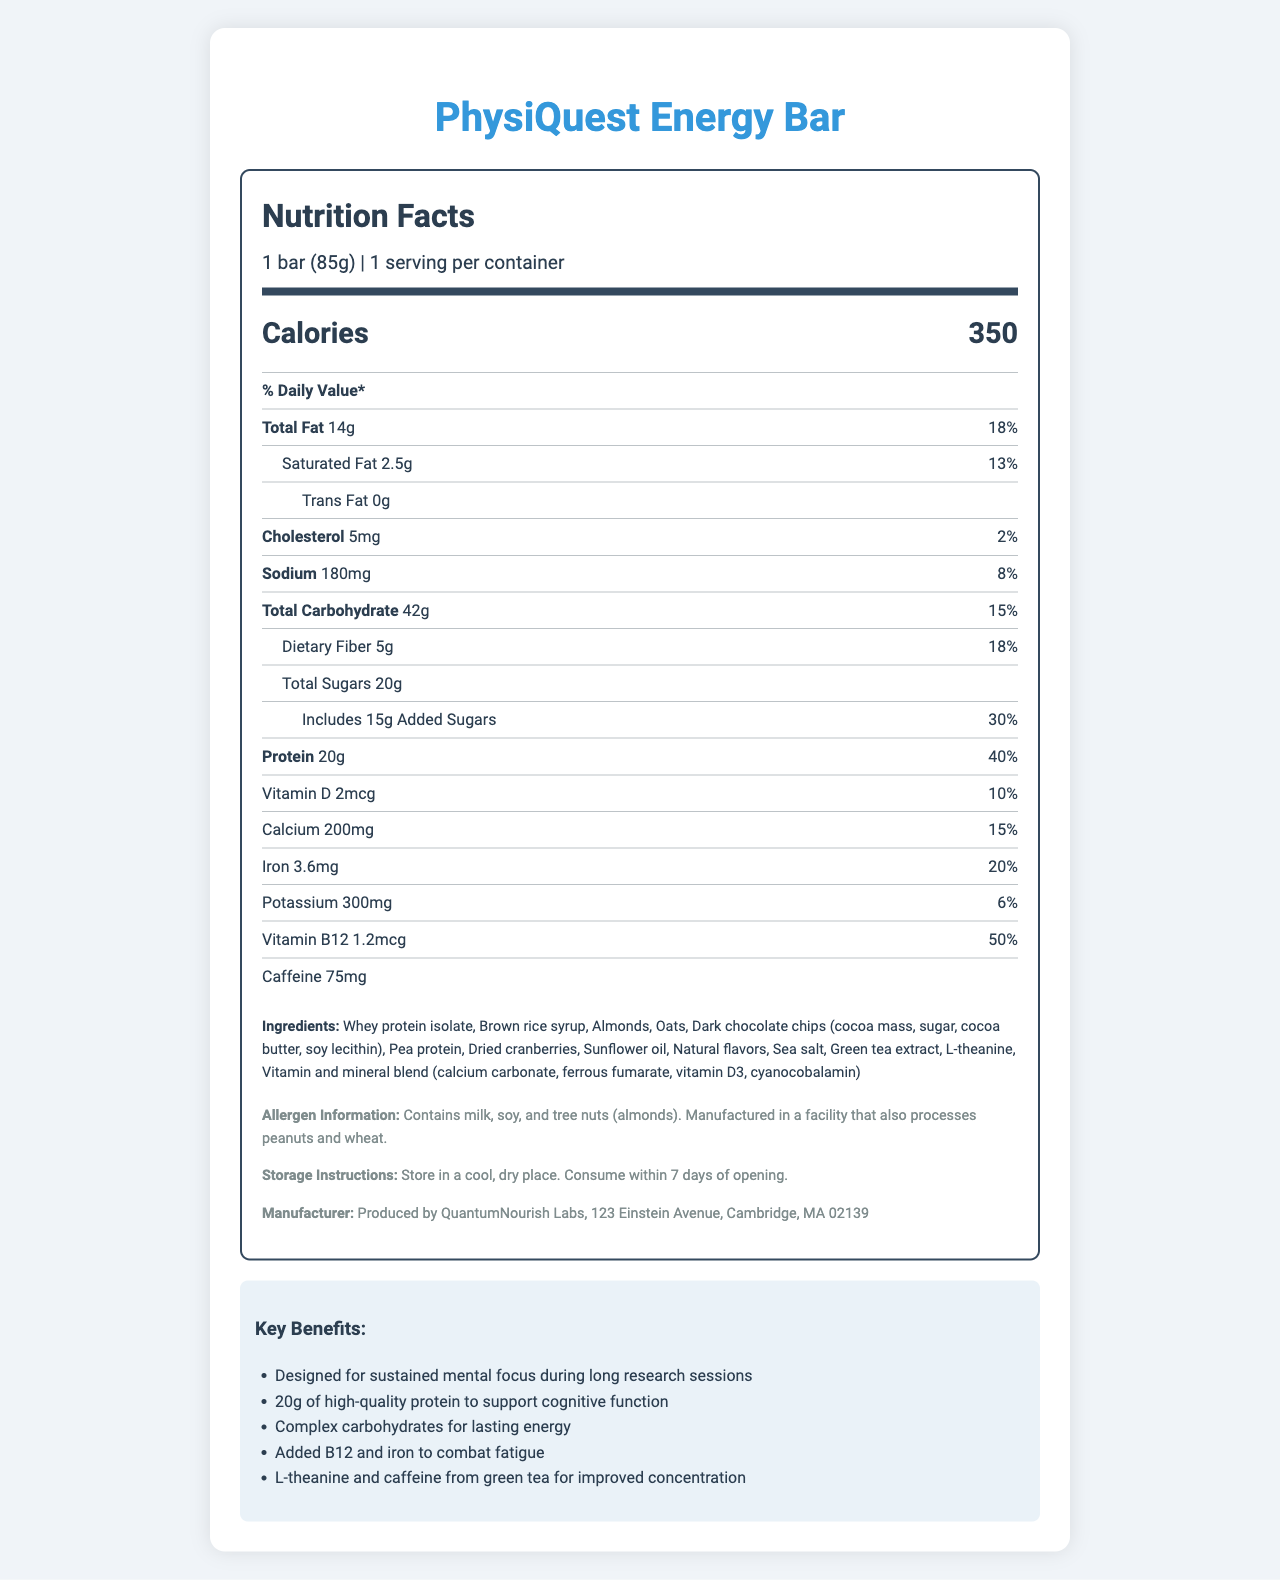What is the serving size of the PhysiQuest Energy Bar? The serving size is mentioned in the nutrition label next to the product name.
Answer: 1 bar (85g) How many calories does one PhysiQuest Energy Bar contain? The number of calories per serving is clearly specified in the document.
Answer: 350 calories What is the total fat content of the bar in grams? The total fat content is listed under the nutrient information section as 14g.
Answer: 14g What percentage of the daily value of protein does one bar provide? The percent daily value of protein is noted as 40%.
Answer: 40% Which ingredients in the bar might cause allergies? The allergen information mentions that the product contains milk, soy, and tree nuts (almonds).
Answer: Milk, soy, and tree nuts (almonds) What are the two key benefits highlighted for the PhysiQuest Energy Bar in terms of cognitive function and energy? These benefits are listed in the claim statements section.
Answer: 20g of high-quality protein to support cognitive function, Complex carbohydrates for lasting energy Which vitamin is present in the highest percentage of daily value in the bar? A. Vitamin D B. Calcium C. Iron D. Vitamin B12 Vitamin B12 is present at 50% of the daily value, which is higher than the percentages for Vitamin D (10%), Calcium (15%), and Iron (20%).
Answer: D. Vitamin B12 How much caffeine does the bar contain? A. 25mg B. 45mg C. 75mg D. 100mg The caffeine content is stated as 75mg.
Answer: C. 75mg Is the bar manufactured in a facility that processes peanuts and wheat? The allergen information mentions that it is manufactured in a facility that processes peanuts and wheat.
Answer: Yes Briefly summarize the document you are reviewing. The label provides essential nutrition and ingredient details along with claims supporting the bar's benefits for mental focus and sustained energy during long research sessions.
Answer: The document is a detailed nutrition facts label for the PhysiQuest Energy Bar, including specific information on serving size, caloric content, nutrients (fats, protein, vitamins, minerals), ingredients, allergen information, and claims about the benefits related to cognitive function and energy. What is the amount of iron provided per bar in milligrams? The amount of iron per bar is listed as 3.6mg.
Answer: 3.6mg What are the added sugars content and its daily value percentage? The added sugars content is 15g with a 30% daily value.
Answer: 15g, 30% Can you determine the exact content of Omega-3 fatty acids in the bar from the document? The document does not provide any information on the Omega-3 fatty acid content.
Answer: Not enough information What is the main difference between Total Sugars and Added Sugars based on the document? The document specifically lists Total Sugars and identifies Added Sugars as a subset with its own amount and daily value percentage.
Answer: Total Sugars include both naturally occurring and added sugars, while Added Sugars are specifically the sugars added during processing. 